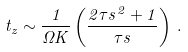Convert formula to latex. <formula><loc_0><loc_0><loc_500><loc_500>t _ { z } \sim \frac { 1 } { \Omega K } \left ( \frac { 2 \tau s ^ { 2 } + 1 } { \tau s } \right ) \, .</formula> 